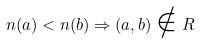<formula> <loc_0><loc_0><loc_500><loc_500>n ( a ) < n ( b ) \Rightarrow ( a , b ) \notin R</formula> 